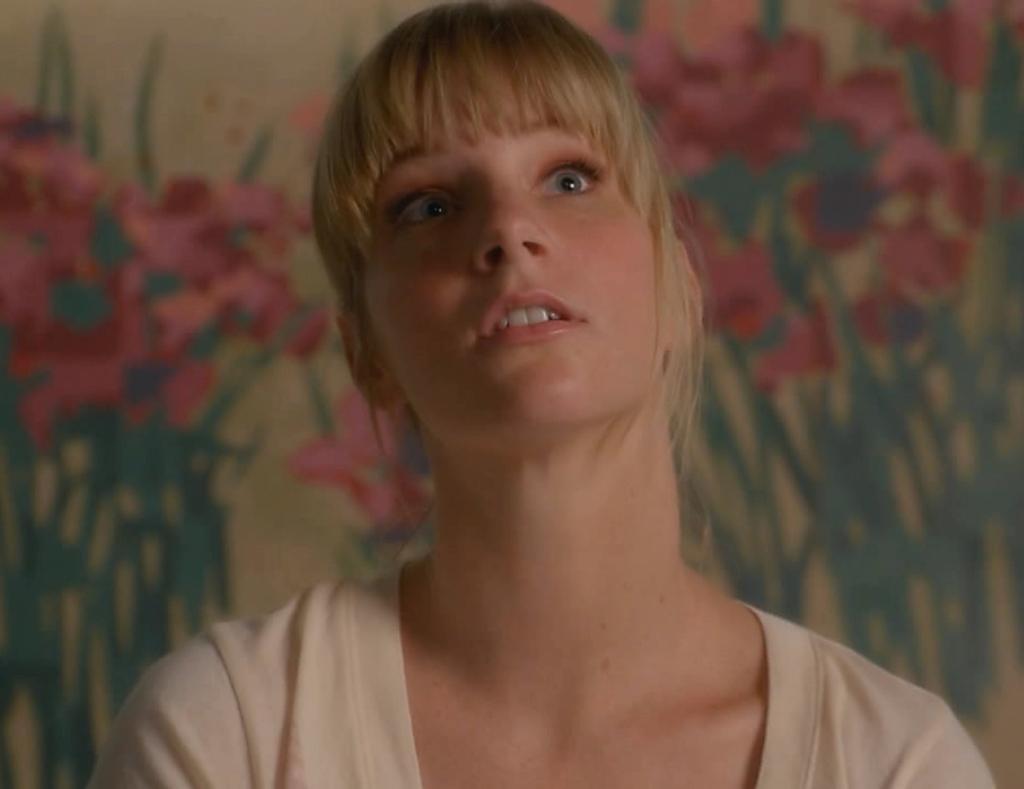Can you describe this image briefly? In this image there is a woman. Behind her there is a wall having the painting of few plants having flowers. 